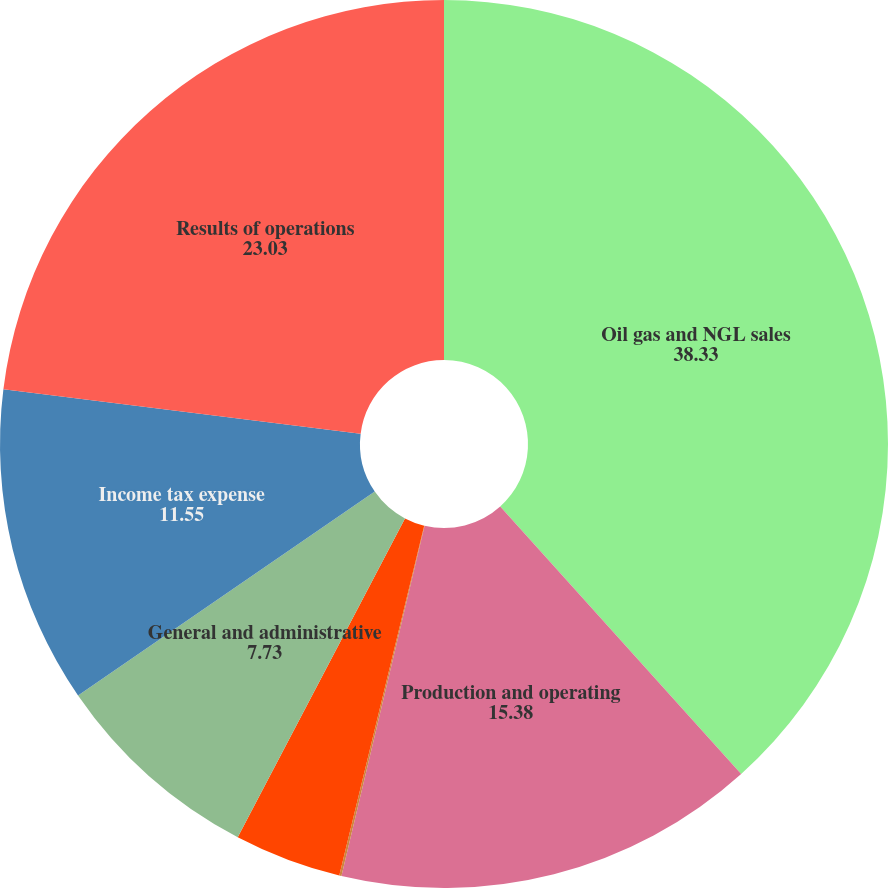Convert chart. <chart><loc_0><loc_0><loc_500><loc_500><pie_chart><fcel>Oil gas and NGL sales<fcel>Production and operating<fcel>Depreciation depletion and<fcel>Accretion of asset retirement<fcel>General and administrative<fcel>Income tax expense<fcel>Results of operations<nl><fcel>38.33%<fcel>15.38%<fcel>0.08%<fcel>3.9%<fcel>7.73%<fcel>11.55%<fcel>23.03%<nl></chart> 